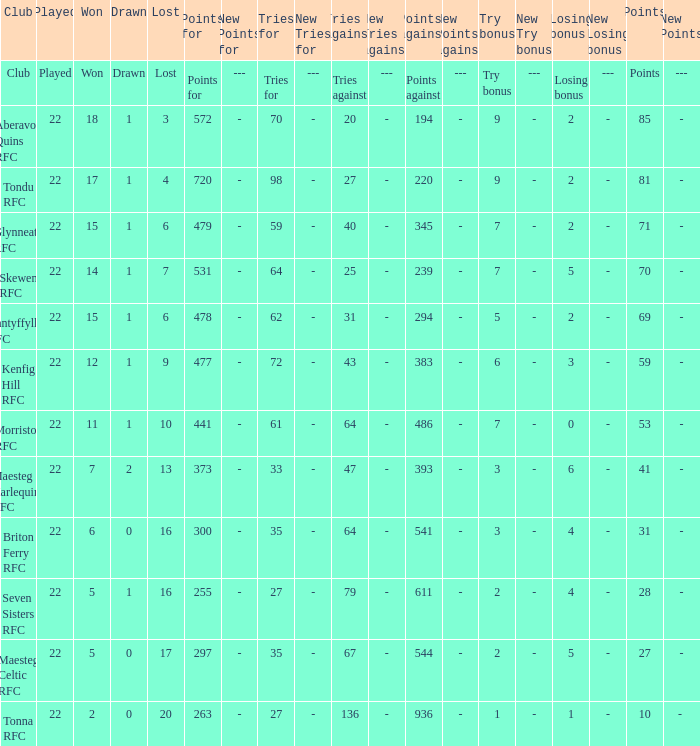How many attempts against has the club with 62 tries for secured? 31.0. 